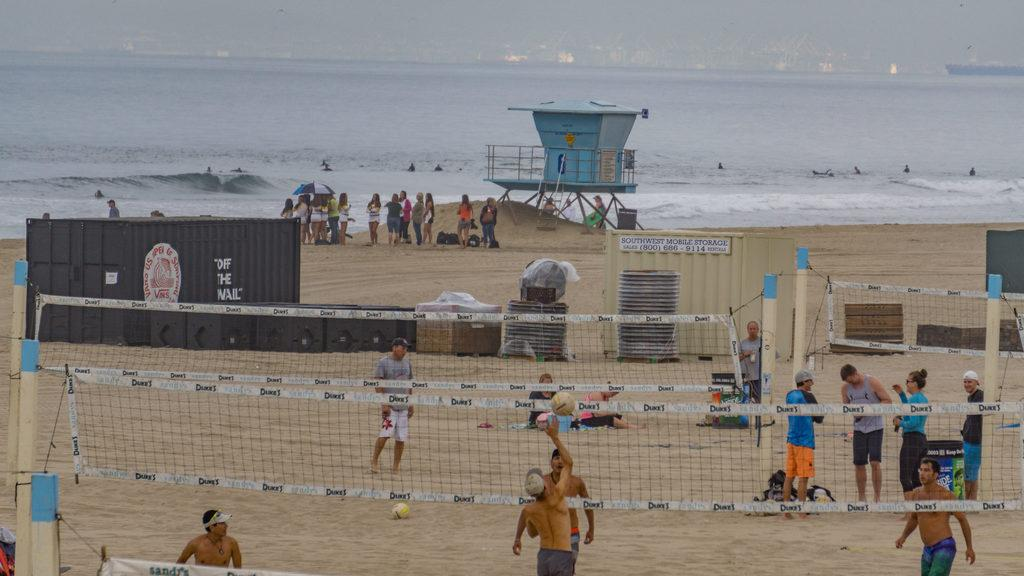What type of location is depicted in the image? There is a beach in the image. What activities are people engaged in on the beach? People are playing with a ball and surfing in the water. Are there any other water-related activities happening in the image? Yes, some people are swimming in the water. What is the purpose of the range in the image? There is no range present in the image; it features a beach with people playing, surfing, and swimming. 